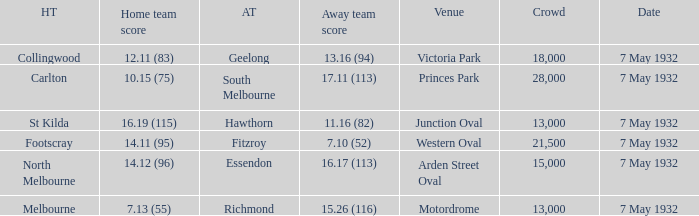What is the largest crowd with Away team score of 13.16 (94)? 18000.0. 